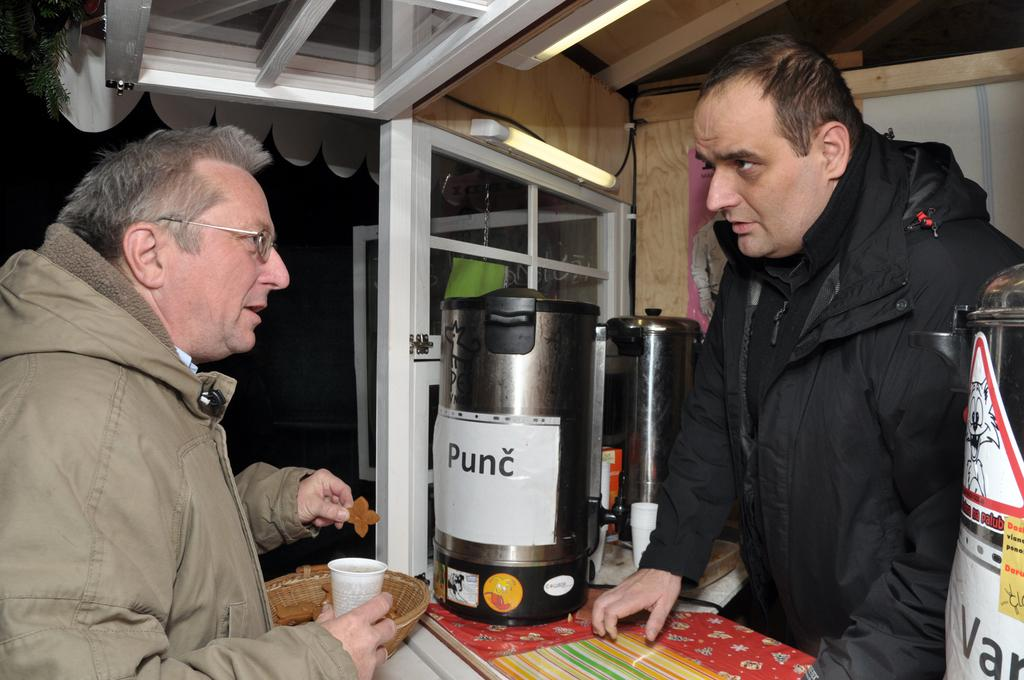<image>
Relay a brief, clear account of the picture shown. A man standing behind a counter with a machine labeled Punc in front of him. 